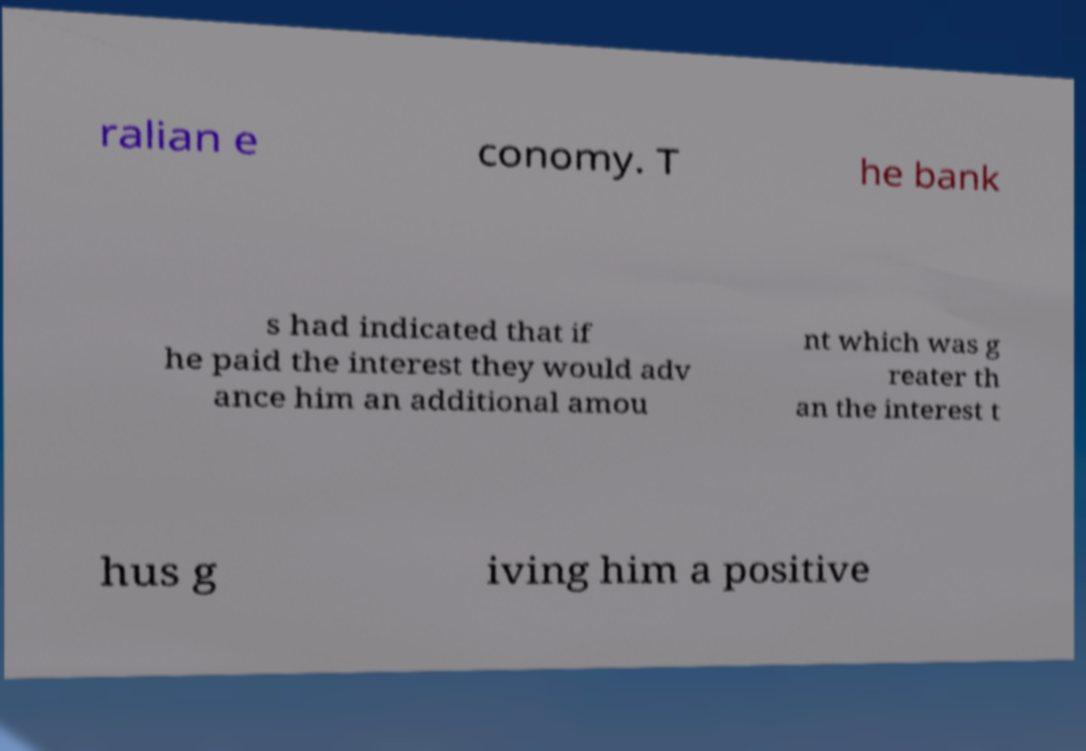There's text embedded in this image that I need extracted. Can you transcribe it verbatim? ralian e conomy. T he bank s had indicated that if he paid the interest they would adv ance him an additional amou nt which was g reater th an the interest t hus g iving him a positive 